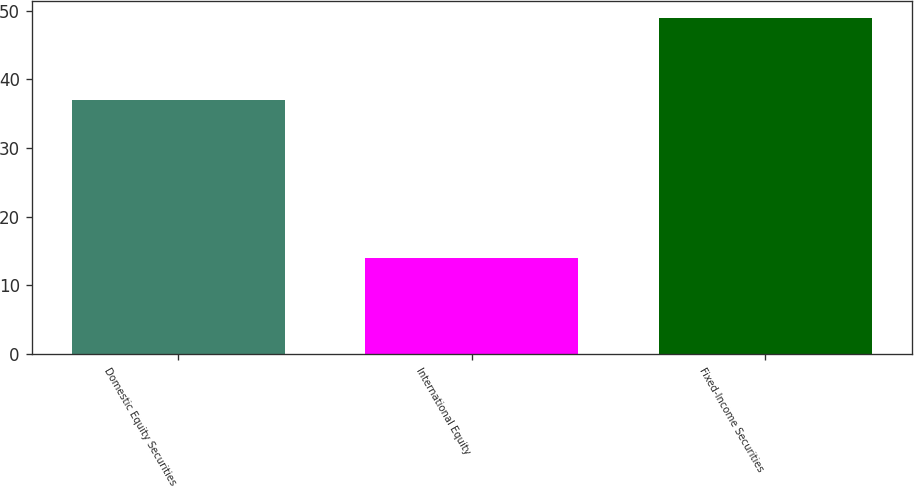Convert chart to OTSL. <chart><loc_0><loc_0><loc_500><loc_500><bar_chart><fcel>Domestic Equity Securities<fcel>International Equity<fcel>Fixed-Income Securities<nl><fcel>37<fcel>14<fcel>49<nl></chart> 